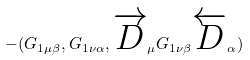Convert formula to latex. <formula><loc_0><loc_0><loc_500><loc_500>- ( G _ { 1 \mu \beta } , G _ { 1 \nu \alpha } , \overrightarrow { D } _ { \mu } G _ { 1 \nu \beta } \overleftarrow { D } _ { \alpha } )</formula> 